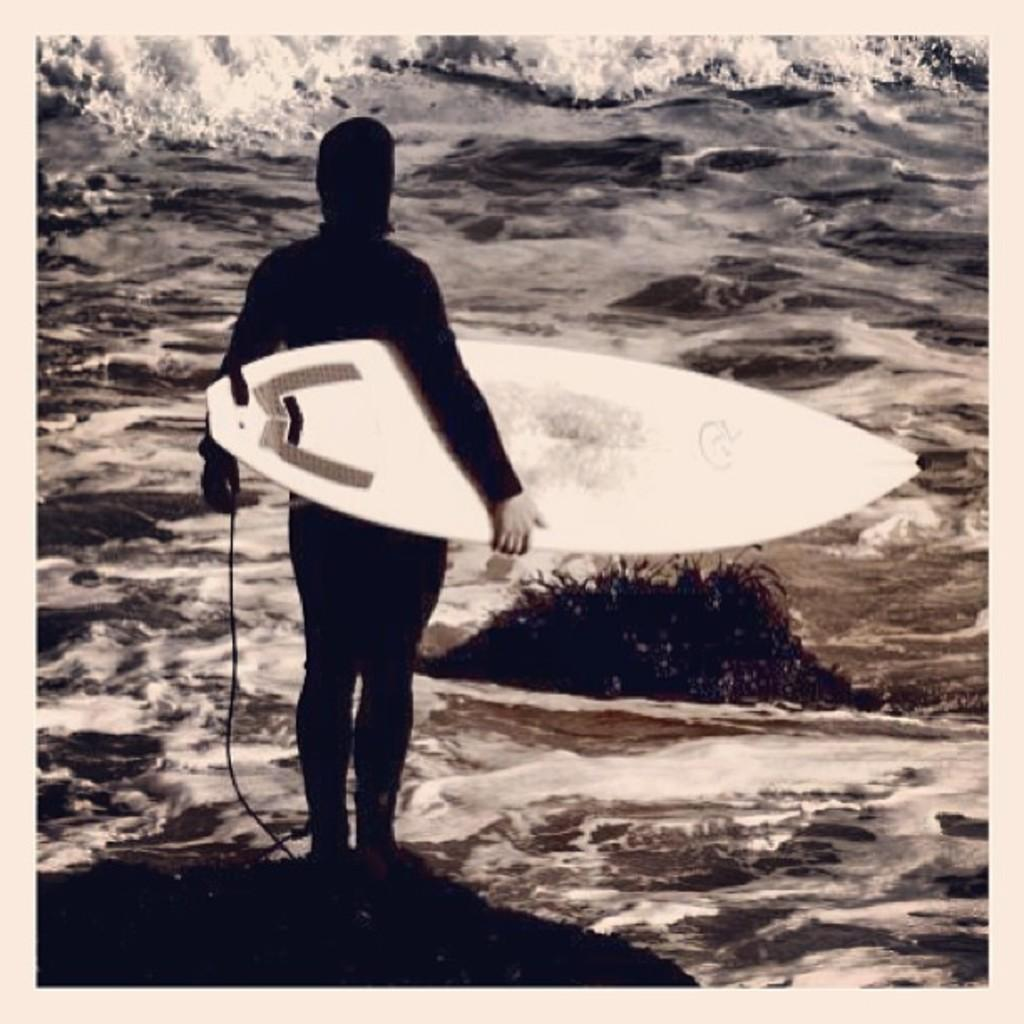What type of water body is shown in the image? The image depicts a freshwater river. Can you describe the person in the image? There is a man standing in the image. What is the man holding in the image? The man is holding a surfboard. What type of scarf is the man wearing in the image? There is no scarf present in the image; the man is holding a surfboard. What division of the company does the man in the image represent? The image does not provide information about the man's affiliation with any company or division. 